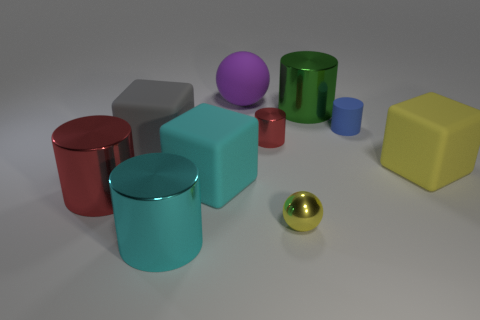Subtract all blue cylinders. How many cylinders are left? 4 Subtract 1 cylinders. How many cylinders are left? 4 Subtract all tiny shiny cylinders. How many cylinders are left? 4 Subtract all cyan cylinders. Subtract all yellow cubes. How many cylinders are left? 4 Subtract all cubes. How many objects are left? 7 Add 8 large purple things. How many large purple things are left? 9 Add 2 gray matte cubes. How many gray matte cubes exist? 3 Subtract 1 red cylinders. How many objects are left? 9 Subtract all big red cylinders. Subtract all big metallic things. How many objects are left? 6 